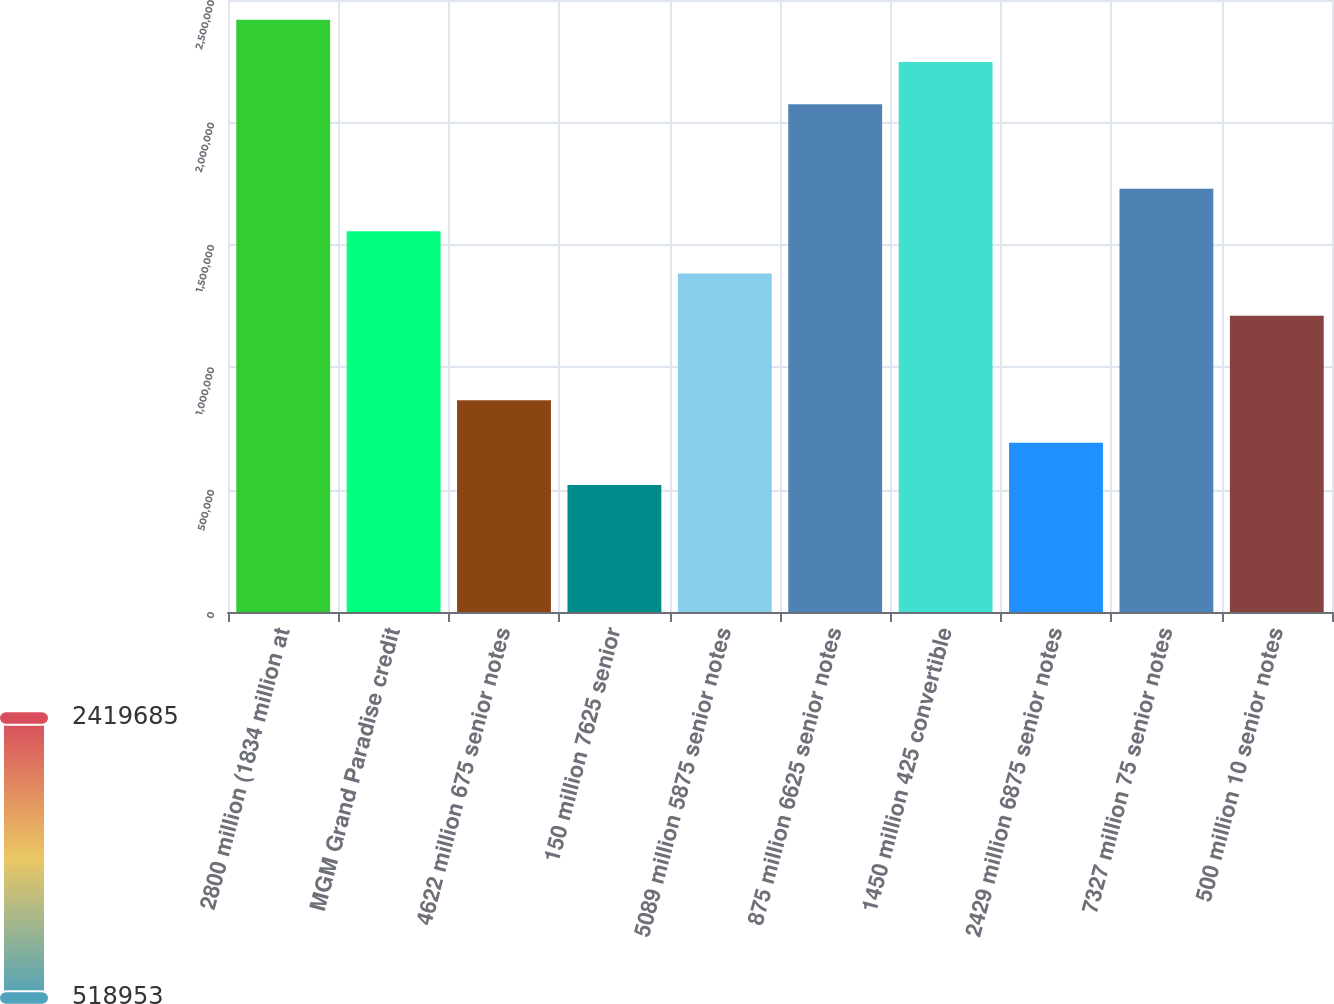<chart> <loc_0><loc_0><loc_500><loc_500><bar_chart><fcel>2800 million (1834 million at<fcel>MGM Grand Paradise credit<fcel>4622 million 675 senior notes<fcel>150 million 7625 senior<fcel>5089 million 5875 senior notes<fcel>875 million 6625 senior notes<fcel>1450 million 425 convertible<fcel>2429 million 6875 senior notes<fcel>7327 million 75 senior notes<fcel>500 million 10 senior notes<nl><fcel>2.41969e+06<fcel>1.55572e+06<fcel>864541<fcel>518953<fcel>1.38292e+06<fcel>2.0741e+06<fcel>2.24689e+06<fcel>691747<fcel>1.72851e+06<fcel>1.21013e+06<nl></chart> 